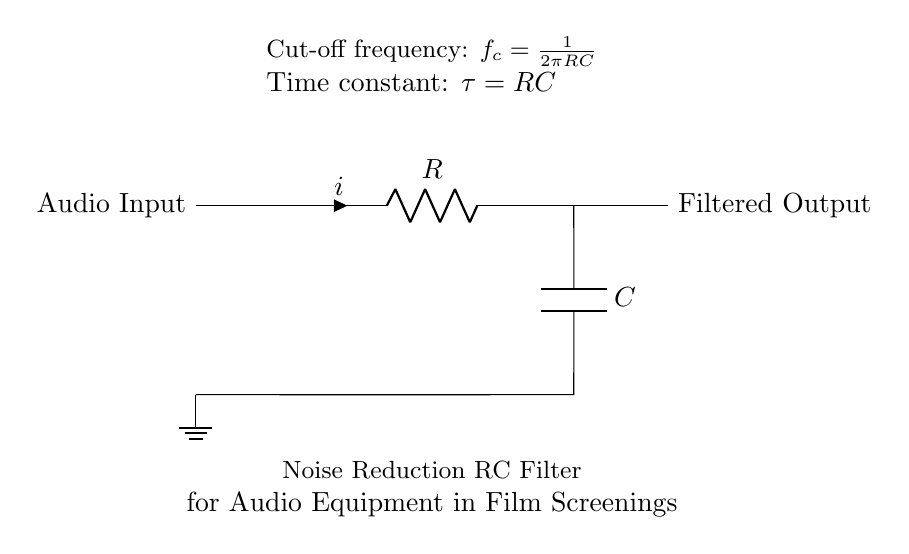What components are present in the circuit? The circuit diagram shows a resistor, a capacitor, and a ground connection. The diagram depicts the resistor marked as R and the capacitor marked as C, both essential for filtering noise in audio signals.
Answer: Resistor, Capacitor What is the purpose of this circuit? The purpose of this circuit is to reduce noise in audio signals, making it suitable for film screenings. The combination of the resistor and capacitor creates a low-pass filter that helps eliminate high-frequency noise.
Answer: Noise reduction What is the cut-off frequency formula? The cut-off frequency formula is given as \( f_c = \frac{1}{2\pi RC} \) which indicates how the resistor and capacitor values determine the frequency at which the filter attenuates signals.
Answer: f_c = 1/(2πRC) What is the time constant of the circuit? The time constant is calculated using the formula \( \tau = RC \). This value indicates how quickly the circuit responds to changes in input voltage, which is crucial for handling audio signals effectively.
Answer: τ = RC How does increasing the resistance affect the cut-off frequency? Increasing the resistance lowers the cut-off frequency because \( f_c \) is inversely proportional to R. This means that with a larger R, the circuit will pass lower frequencies more effectively while blocking higher ones.
Answer: Lower cut-off frequency What happens to the output when the frequency exceeds the cut-off frequency? When the frequency exceeds the cut-off frequency, the output signal will attenuate significantly, resulting in reduced amplitude of those high-frequency components in the audio signal.
Answer: Attenuates high frequencies 